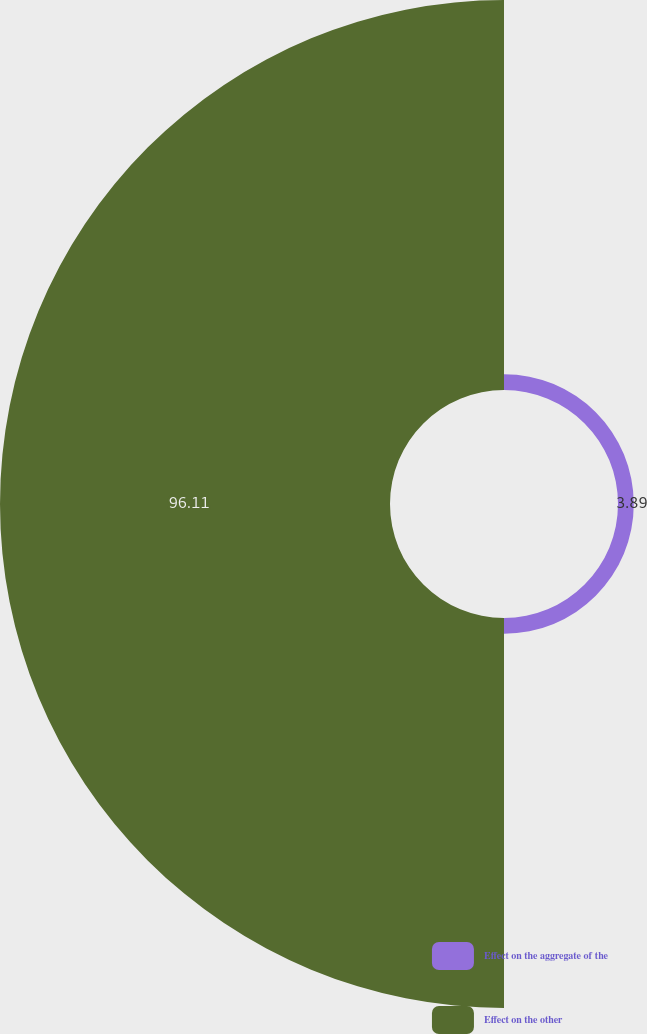<chart> <loc_0><loc_0><loc_500><loc_500><pie_chart><fcel>Effect on the aggregate of the<fcel>Effect on the other<nl><fcel>3.89%<fcel>96.11%<nl></chart> 